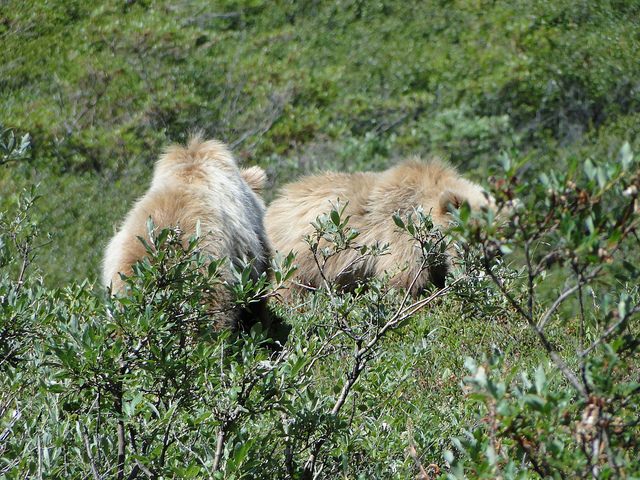Describe the animals' activity you observe in the photo. The animals appear to be resting or foraging within the bushes. Their fur blends into the natural environment, perhaps as a form of camouflage from predators or while hunting prey. 